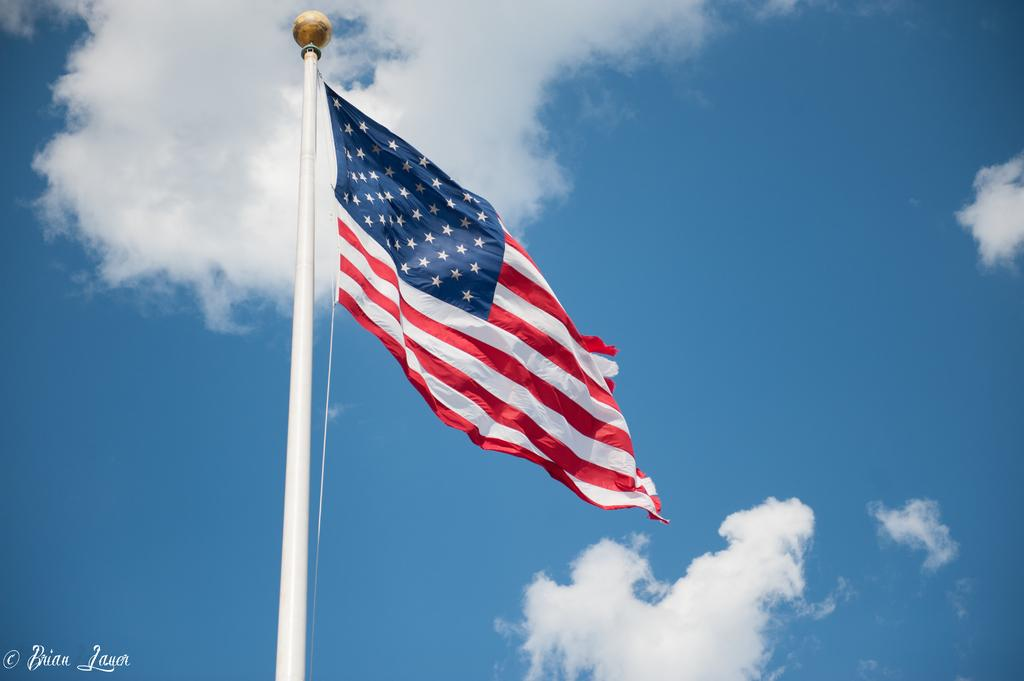What is the main object in the image? There is a flag with a pole in the image. Are there any additional elements in the image? Yes, there is a watermark in the left corner of the image. What can be seen in the background of the image? Sky is visible in the background of the image. What is the condition of the sky in the image? Clouds are present in the sky. Where are the dolls placed in the image? There are no dolls present in the image. What type of bucket can be seen in the image? There is no bucket present in the image. 